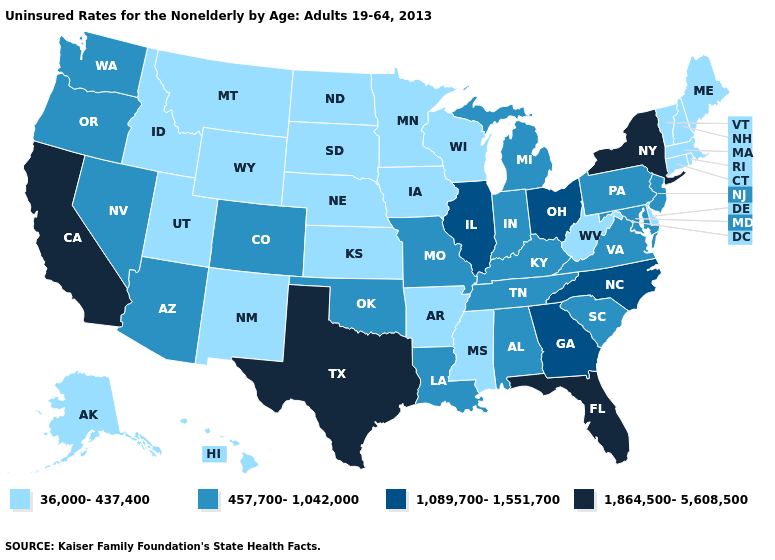Does California have the highest value in the West?
Be succinct. Yes. What is the value of Oklahoma?
Answer briefly. 457,700-1,042,000. Does Utah have a higher value than Iowa?
Quick response, please. No. Does Minnesota have the same value as Iowa?
Short answer required. Yes. Is the legend a continuous bar?
Write a very short answer. No. Does California have the highest value in the USA?
Short answer required. Yes. Does Texas have the highest value in the USA?
Be succinct. Yes. Does Pennsylvania have the lowest value in the Northeast?
Keep it brief. No. How many symbols are there in the legend?
Give a very brief answer. 4. Which states have the highest value in the USA?
Write a very short answer. California, Florida, New York, Texas. Name the states that have a value in the range 1,089,700-1,551,700?
Keep it brief. Georgia, Illinois, North Carolina, Ohio. Does Oregon have the lowest value in the West?
Short answer required. No. Which states hav the highest value in the Northeast?
Keep it brief. New York. Does Tennessee have the lowest value in the South?
Give a very brief answer. No. What is the value of New Hampshire?
Keep it brief. 36,000-437,400. 